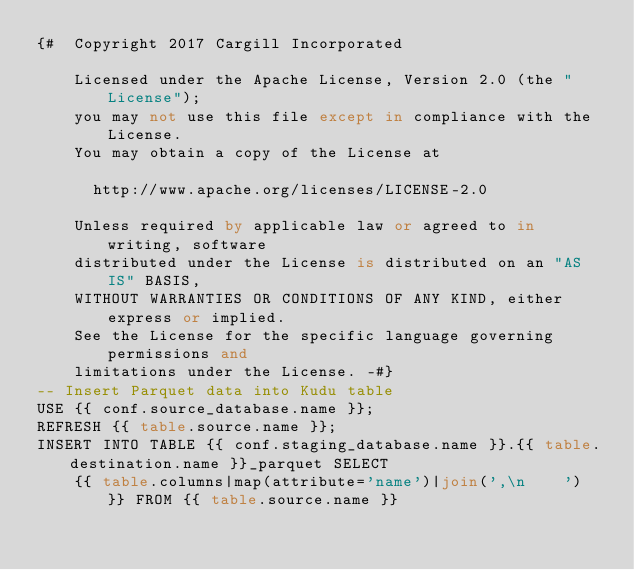<code> <loc_0><loc_0><loc_500><loc_500><_SQL_>{#  Copyright 2017 Cargill Incorporated

    Licensed under the Apache License, Version 2.0 (the "License");
    you may not use this file except in compliance with the License.
    You may obtain a copy of the License at

      http://www.apache.org/licenses/LICENSE-2.0

    Unless required by applicable law or agreed to in writing, software
    distributed under the License is distributed on an "AS IS" BASIS,
    WITHOUT WARRANTIES OR CONDITIONS OF ANY KIND, either express or implied.
    See the License for the specific language governing permissions and
    limitations under the License. -#}
-- Insert Parquet data into Kudu table
USE {{ conf.source_database.name }};
REFRESH {{ table.source.name }};
INSERT INTO TABLE {{ conf.staging_database.name }}.{{ table.destination.name }}_parquet SELECT
    {{ table.columns|map(attribute='name')|join(',\n    ') }} FROM {{ table.source.name }}
</code> 